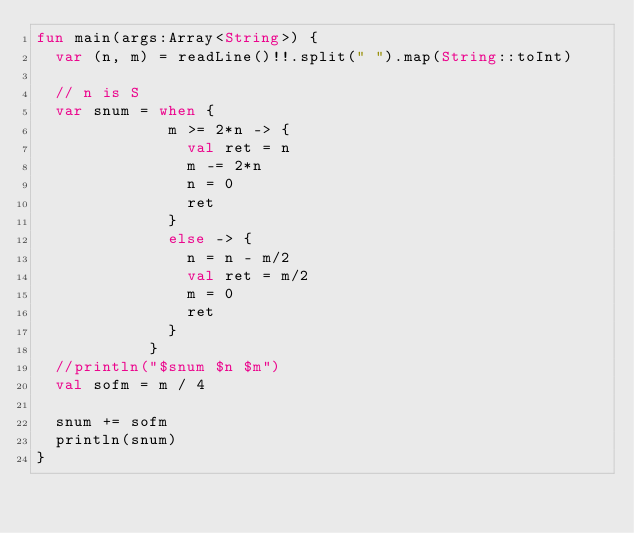<code> <loc_0><loc_0><loc_500><loc_500><_Kotlin_>fun main(args:Array<String>) {
  var (n, m) = readLine()!!.split(" ").map(String::toInt)

  // n is S
  var snum = when { 
              m >= 2*n -> { 
                val ret = n
                m -= 2*n
                n = 0
                ret
              }
              else -> { 
                n = n - m/2
                val ret = m/2
                m = 0
                ret 
              }
            }
  //println("$snum $n $m")
  val sofm = m / 4 
  
  snum += sofm
  println(snum)
}
</code> 